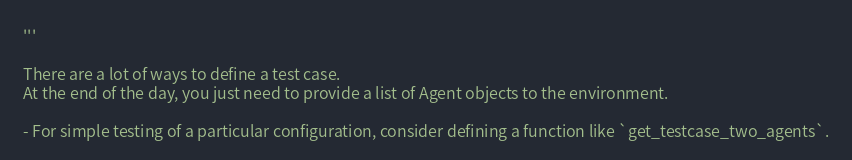<code> <loc_0><loc_0><loc_500><loc_500><_Python_>'''

There are a lot of ways to define a test case.
At the end of the day, you just need to provide a list of Agent objects to the environment.

- For simple testing of a particular configuration, consider defining a function like `get_testcase_two_agents`.</code> 